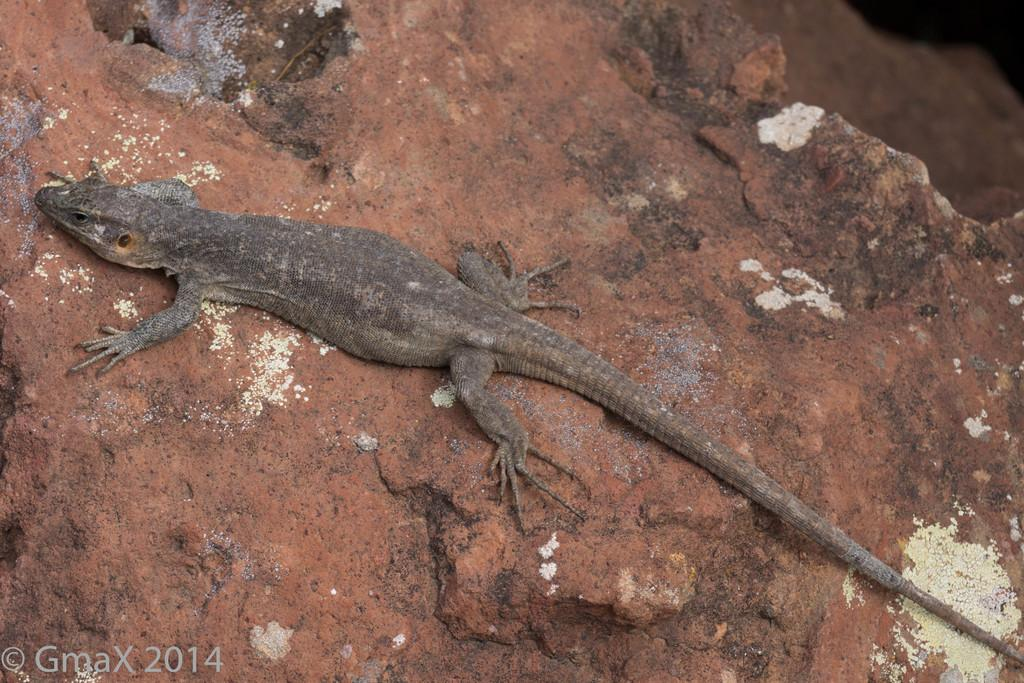What type of animal is in the image? There is a lizard in the image. What colors can be seen on the lizard? The lizard is black and brown in color. What is the lizard resting on in the image? The lizard is on a rock. What colors can be seen on the rock? The rock is brown and white in color. What type of vest is the beggar wearing in the image? There is no beggar or vest present in the image; it features a lizard on a rock. 